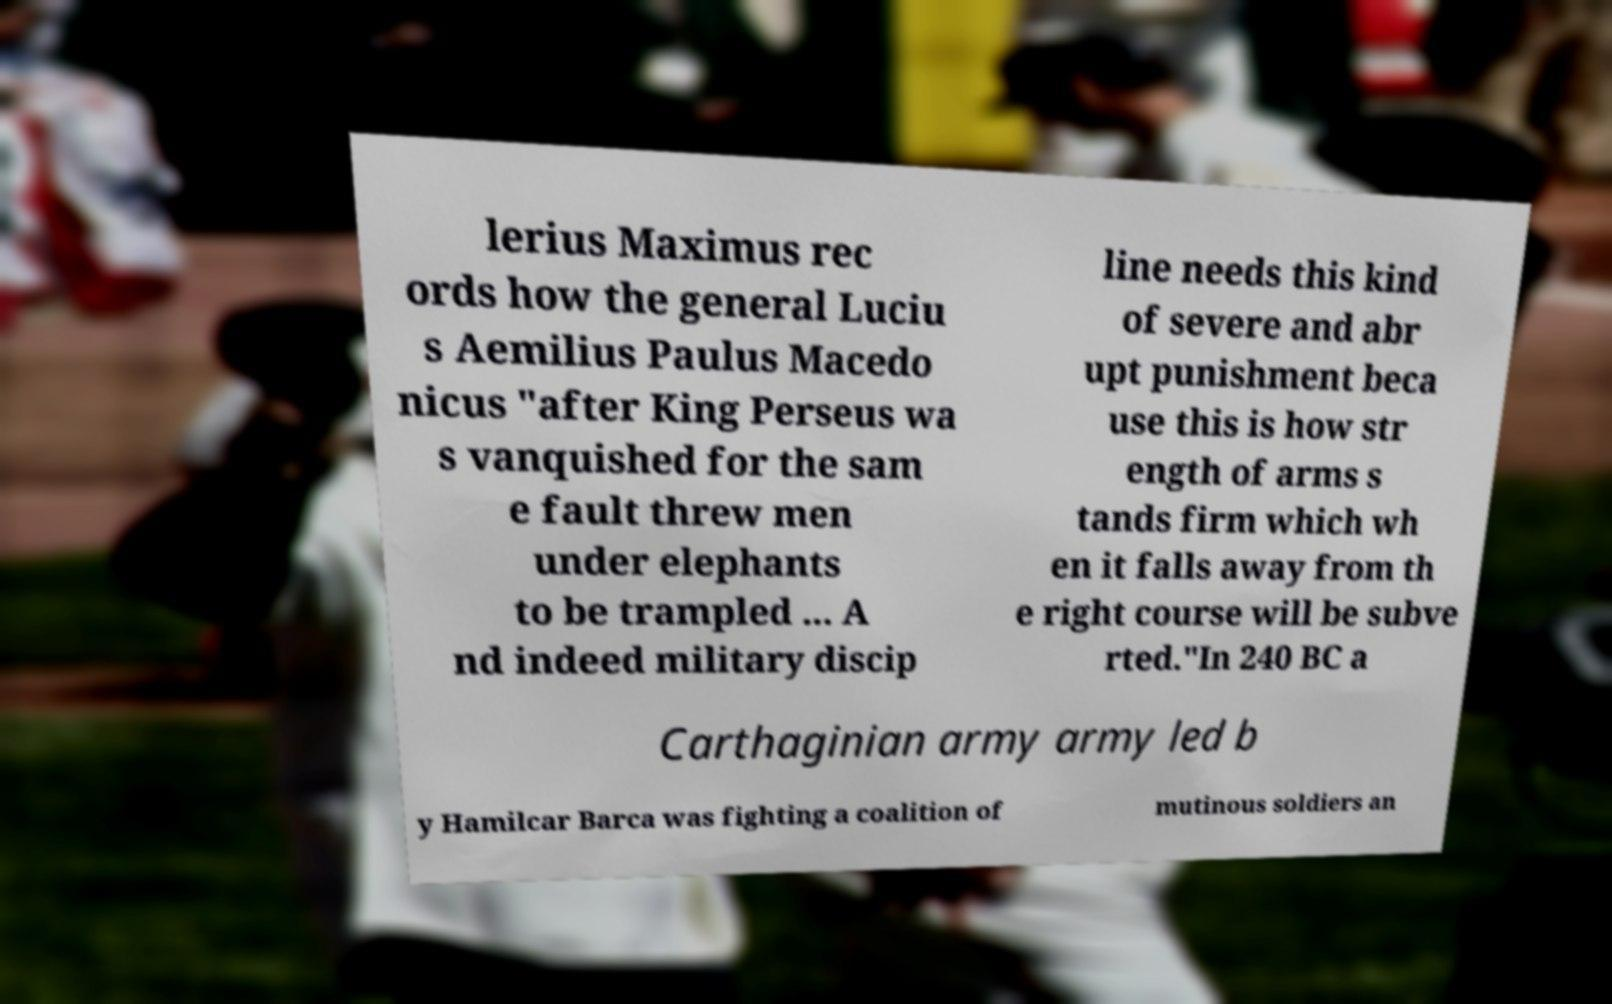For documentation purposes, I need the text within this image transcribed. Could you provide that? lerius Maximus rec ords how the general Luciu s Aemilius Paulus Macedo nicus "after King Perseus wa s vanquished for the sam e fault threw men under elephants to be trampled ... A nd indeed military discip line needs this kind of severe and abr upt punishment beca use this is how str ength of arms s tands firm which wh en it falls away from th e right course will be subve rted."In 240 BC a Carthaginian army army led b y Hamilcar Barca was fighting a coalition of mutinous soldiers an 